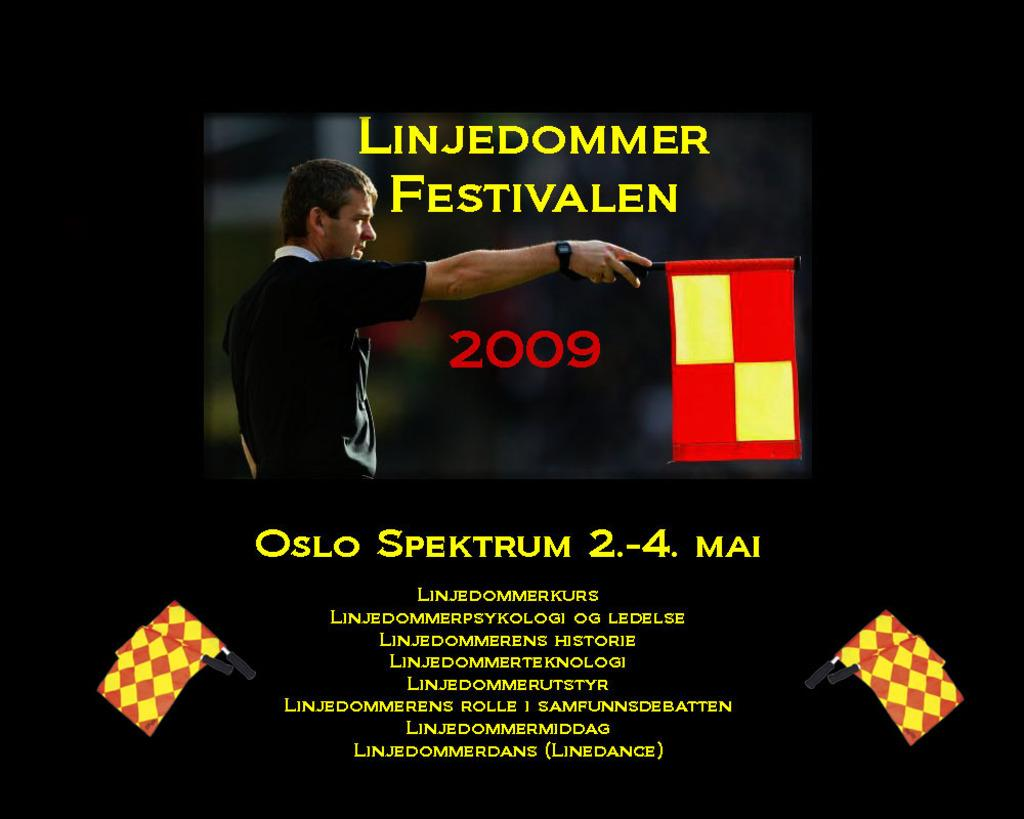What is the man in the image holding? The man is holding a flag in the image. What is the man wearing on his upper body? The man is wearing a black T-shirt in the image. What accessory is the man wearing on his wrist? The man is wearing a watch in the image. What type of sleet can be seen falling in the image? There is no sleet present in the image; it is a picture of a man holding a flag and wearing a black T-shirt and a watch. 